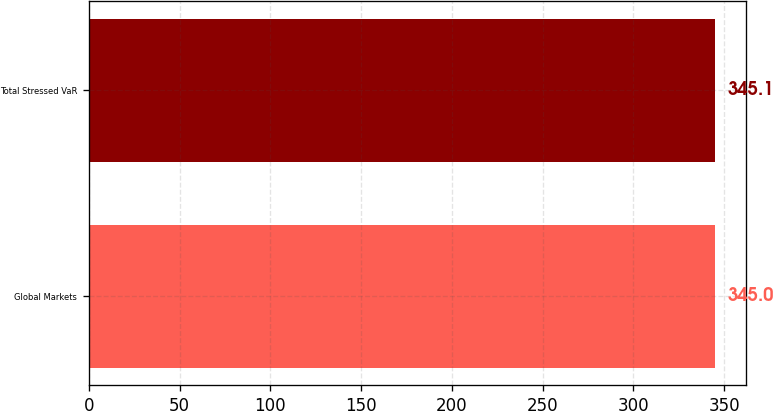Convert chart to OTSL. <chart><loc_0><loc_0><loc_500><loc_500><bar_chart><fcel>Global Markets<fcel>Total Stressed VaR<nl><fcel>345<fcel>345.1<nl></chart> 